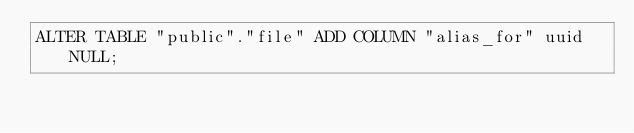Convert code to text. <code><loc_0><loc_0><loc_500><loc_500><_SQL_>ALTER TABLE "public"."file" ADD COLUMN "alias_for" uuid NULL;
</code> 